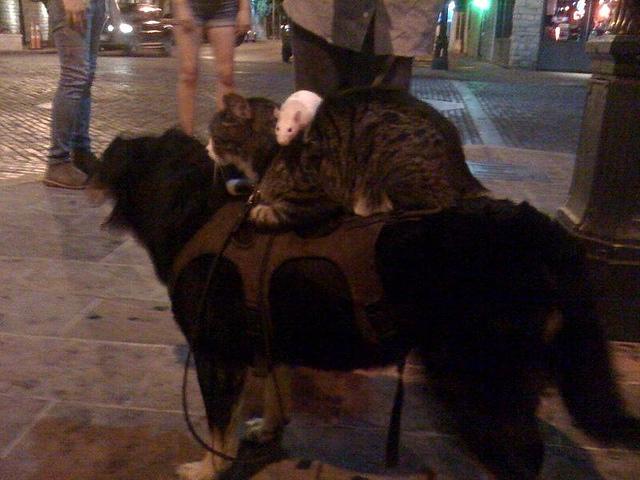Is the mouse real?
Short answer required. Yes. What is on top of the dogs back?
Be succinct. Cat and mouse. What is on top of the cats back?
Write a very short answer. Rat. 